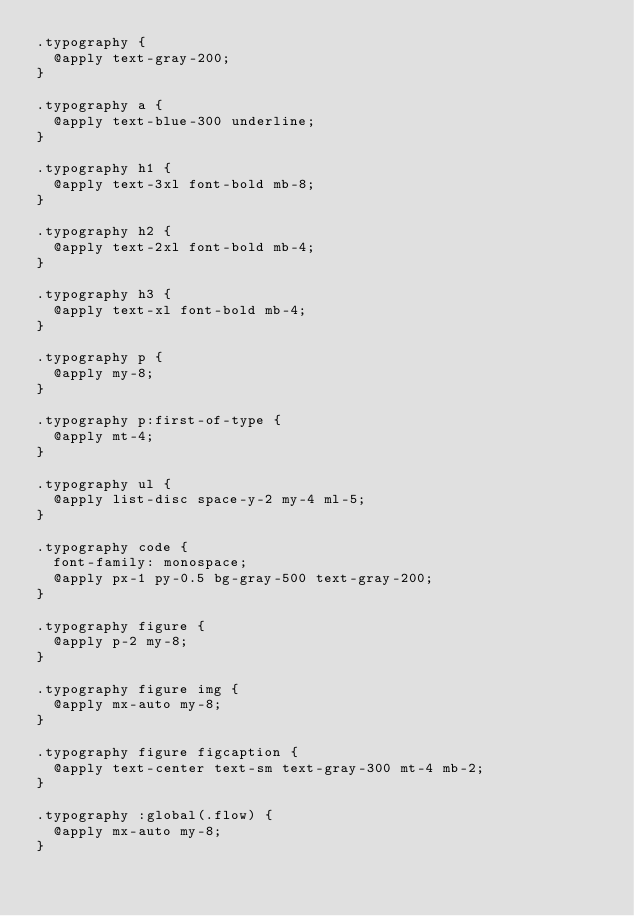Convert code to text. <code><loc_0><loc_0><loc_500><loc_500><_CSS_>.typography {
	@apply text-gray-200;
}

.typography a {
	@apply text-blue-300 underline;
}

.typography h1 {
	@apply text-3xl font-bold mb-8;
}

.typography h2 {
	@apply text-2xl font-bold mb-4;
}

.typography h3 {
	@apply text-xl font-bold mb-4;
}

.typography p {
	@apply my-8;
}

.typography p:first-of-type {
	@apply mt-4;
}

.typography ul {
	@apply list-disc space-y-2 my-4 ml-5;
}

.typography code {
	font-family: monospace;
	@apply px-1 py-0.5 bg-gray-500 text-gray-200;
}

.typography figure {
	@apply p-2 my-8;
}

.typography figure img {
	@apply mx-auto my-8;
}

.typography figure figcaption {
	@apply text-center text-sm text-gray-300 mt-4 mb-2;
}

.typography :global(.flow) {
	@apply mx-auto my-8;
}
</code> 